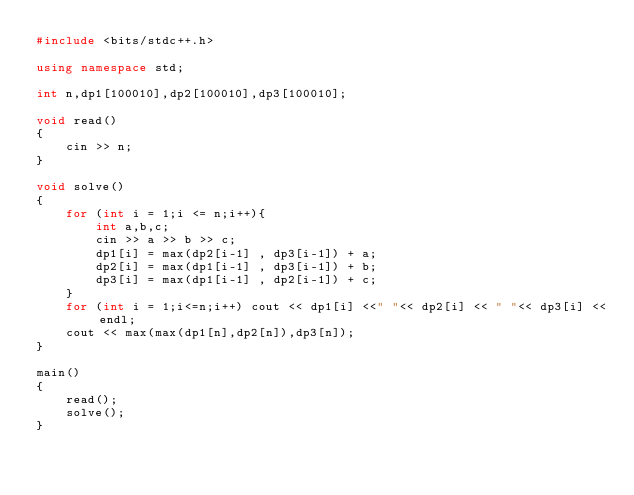Convert code to text. <code><loc_0><loc_0><loc_500><loc_500><_C++_>#include <bits/stdc++.h>

using namespace std;

int n,dp1[100010],dp2[100010],dp3[100010];

void read()
{
    cin >> n;
}

void solve()
{
    for (int i = 1;i <= n;i++){
        int a,b,c;
        cin >> a >> b >> c;
        dp1[i] = max(dp2[i-1] , dp3[i-1]) + a;
        dp2[i] = max(dp1[i-1] , dp3[i-1]) + b;
        dp3[i] = max(dp1[i-1] , dp2[i-1]) + c;
    }
    for (int i = 1;i<=n;i++) cout << dp1[i] <<" "<< dp2[i] << " "<< dp3[i] <<endl;
    cout << max(max(dp1[n],dp2[n]),dp3[n]);
}

main()
{
    read();
    solve();
}
</code> 